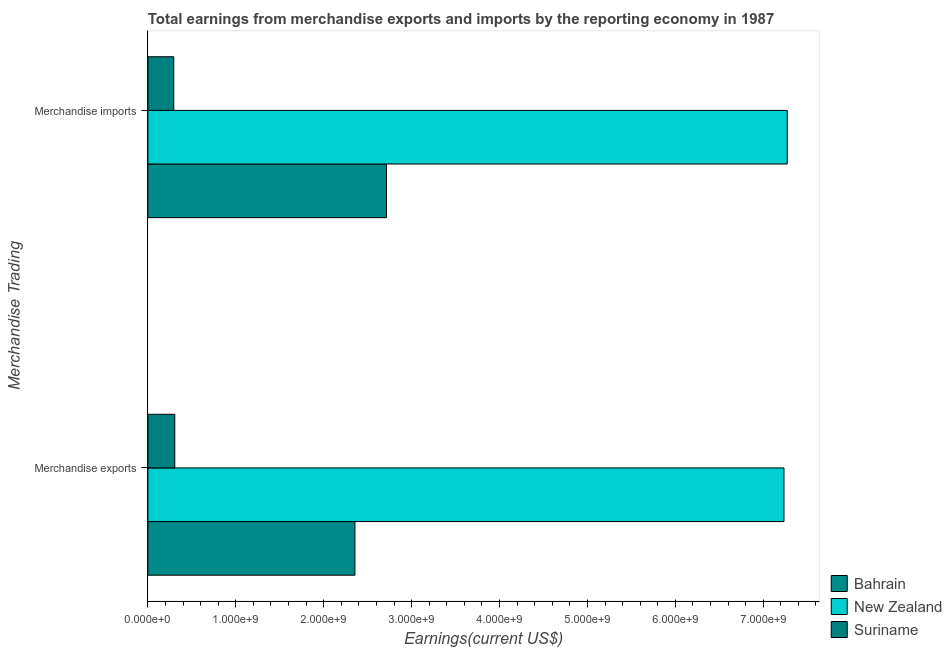How many different coloured bars are there?
Offer a very short reply. 3. How many groups of bars are there?
Your answer should be very brief. 2. Are the number of bars per tick equal to the number of legend labels?
Offer a terse response. Yes. How many bars are there on the 1st tick from the top?
Your answer should be compact. 3. How many bars are there on the 2nd tick from the bottom?
Your answer should be very brief. 3. What is the label of the 2nd group of bars from the top?
Your answer should be very brief. Merchandise exports. What is the earnings from merchandise imports in New Zealand?
Your answer should be very brief. 7.27e+09. Across all countries, what is the maximum earnings from merchandise imports?
Your answer should be very brief. 7.27e+09. Across all countries, what is the minimum earnings from merchandise imports?
Provide a short and direct response. 2.95e+08. In which country was the earnings from merchandise imports maximum?
Provide a short and direct response. New Zealand. In which country was the earnings from merchandise exports minimum?
Ensure brevity in your answer.  Suriname. What is the total earnings from merchandise imports in the graph?
Offer a very short reply. 1.03e+1. What is the difference between the earnings from merchandise imports in Bahrain and that in New Zealand?
Provide a short and direct response. -4.56e+09. What is the difference between the earnings from merchandise exports in Suriname and the earnings from merchandise imports in New Zealand?
Offer a terse response. -6.97e+09. What is the average earnings from merchandise exports per country?
Provide a succinct answer. 3.30e+09. What is the difference between the earnings from merchandise exports and earnings from merchandise imports in New Zealand?
Provide a short and direct response. -3.73e+07. In how many countries, is the earnings from merchandise exports greater than 6400000000 US$?
Ensure brevity in your answer.  1. What is the ratio of the earnings from merchandise exports in Bahrain to that in Suriname?
Your response must be concise. 7.69. Is the earnings from merchandise imports in Bahrain less than that in Suriname?
Provide a short and direct response. No. What does the 3rd bar from the top in Merchandise imports represents?
Your response must be concise. Bahrain. What does the 2nd bar from the bottom in Merchandise imports represents?
Ensure brevity in your answer.  New Zealand. Are all the bars in the graph horizontal?
Keep it short and to the point. Yes. What is the difference between two consecutive major ticks on the X-axis?
Make the answer very short. 1.00e+09. Does the graph contain grids?
Offer a terse response. No. Where does the legend appear in the graph?
Offer a terse response. Bottom right. What is the title of the graph?
Make the answer very short. Total earnings from merchandise exports and imports by the reporting economy in 1987. What is the label or title of the X-axis?
Offer a terse response. Earnings(current US$). What is the label or title of the Y-axis?
Provide a succinct answer. Merchandise Trading. What is the Earnings(current US$) of Bahrain in Merchandise exports?
Your response must be concise. 2.36e+09. What is the Earnings(current US$) in New Zealand in Merchandise exports?
Keep it short and to the point. 7.24e+09. What is the Earnings(current US$) of Suriname in Merchandise exports?
Your answer should be very brief. 3.06e+08. What is the Earnings(current US$) of Bahrain in Merchandise imports?
Your answer should be compact. 2.71e+09. What is the Earnings(current US$) of New Zealand in Merchandise imports?
Offer a terse response. 7.27e+09. What is the Earnings(current US$) in Suriname in Merchandise imports?
Offer a terse response. 2.95e+08. Across all Merchandise Trading, what is the maximum Earnings(current US$) in Bahrain?
Your answer should be compact. 2.71e+09. Across all Merchandise Trading, what is the maximum Earnings(current US$) of New Zealand?
Keep it short and to the point. 7.27e+09. Across all Merchandise Trading, what is the maximum Earnings(current US$) of Suriname?
Provide a short and direct response. 3.06e+08. Across all Merchandise Trading, what is the minimum Earnings(current US$) of Bahrain?
Offer a very short reply. 2.36e+09. Across all Merchandise Trading, what is the minimum Earnings(current US$) in New Zealand?
Make the answer very short. 7.24e+09. Across all Merchandise Trading, what is the minimum Earnings(current US$) of Suriname?
Give a very brief answer. 2.95e+08. What is the total Earnings(current US$) of Bahrain in the graph?
Give a very brief answer. 5.07e+09. What is the total Earnings(current US$) of New Zealand in the graph?
Keep it short and to the point. 1.45e+1. What is the total Earnings(current US$) in Suriname in the graph?
Provide a short and direct response. 6.01e+08. What is the difference between the Earnings(current US$) of Bahrain in Merchandise exports and that in Merchandise imports?
Provide a succinct answer. -3.58e+08. What is the difference between the Earnings(current US$) in New Zealand in Merchandise exports and that in Merchandise imports?
Keep it short and to the point. -3.73e+07. What is the difference between the Earnings(current US$) of Suriname in Merchandise exports and that in Merchandise imports?
Your answer should be very brief. 1.16e+07. What is the difference between the Earnings(current US$) of Bahrain in Merchandise exports and the Earnings(current US$) of New Zealand in Merchandise imports?
Provide a succinct answer. -4.92e+09. What is the difference between the Earnings(current US$) of Bahrain in Merchandise exports and the Earnings(current US$) of Suriname in Merchandise imports?
Offer a terse response. 2.06e+09. What is the difference between the Earnings(current US$) of New Zealand in Merchandise exports and the Earnings(current US$) of Suriname in Merchandise imports?
Your response must be concise. 6.94e+09. What is the average Earnings(current US$) in Bahrain per Merchandise Trading?
Your answer should be very brief. 2.53e+09. What is the average Earnings(current US$) of New Zealand per Merchandise Trading?
Keep it short and to the point. 7.25e+09. What is the average Earnings(current US$) of Suriname per Merchandise Trading?
Provide a succinct answer. 3.00e+08. What is the difference between the Earnings(current US$) in Bahrain and Earnings(current US$) in New Zealand in Merchandise exports?
Give a very brief answer. -4.88e+09. What is the difference between the Earnings(current US$) of Bahrain and Earnings(current US$) of Suriname in Merchandise exports?
Your answer should be compact. 2.05e+09. What is the difference between the Earnings(current US$) of New Zealand and Earnings(current US$) of Suriname in Merchandise exports?
Ensure brevity in your answer.  6.93e+09. What is the difference between the Earnings(current US$) of Bahrain and Earnings(current US$) of New Zealand in Merchandise imports?
Offer a very short reply. -4.56e+09. What is the difference between the Earnings(current US$) in Bahrain and Earnings(current US$) in Suriname in Merchandise imports?
Your answer should be very brief. 2.42e+09. What is the difference between the Earnings(current US$) of New Zealand and Earnings(current US$) of Suriname in Merchandise imports?
Provide a succinct answer. 6.98e+09. What is the ratio of the Earnings(current US$) of Bahrain in Merchandise exports to that in Merchandise imports?
Provide a short and direct response. 0.87. What is the ratio of the Earnings(current US$) in Suriname in Merchandise exports to that in Merchandise imports?
Give a very brief answer. 1.04. What is the difference between the highest and the second highest Earnings(current US$) in Bahrain?
Keep it short and to the point. 3.58e+08. What is the difference between the highest and the second highest Earnings(current US$) of New Zealand?
Your answer should be very brief. 3.73e+07. What is the difference between the highest and the second highest Earnings(current US$) in Suriname?
Your answer should be very brief. 1.16e+07. What is the difference between the highest and the lowest Earnings(current US$) of Bahrain?
Provide a succinct answer. 3.58e+08. What is the difference between the highest and the lowest Earnings(current US$) of New Zealand?
Provide a short and direct response. 3.73e+07. What is the difference between the highest and the lowest Earnings(current US$) in Suriname?
Offer a terse response. 1.16e+07. 